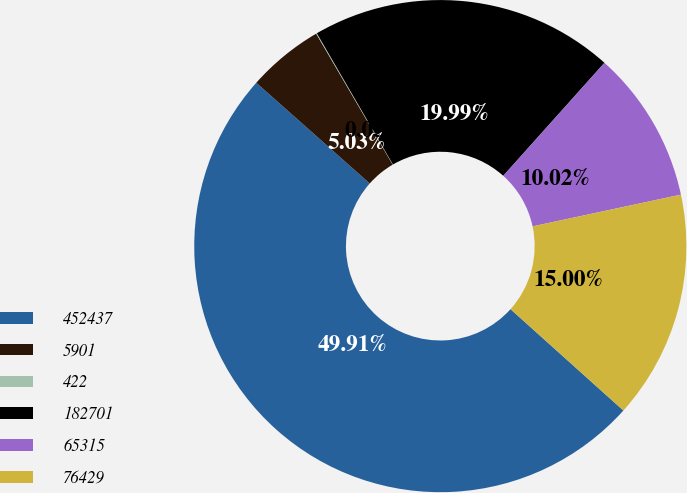Convert chart. <chart><loc_0><loc_0><loc_500><loc_500><pie_chart><fcel>452437<fcel>5901<fcel>422<fcel>182701<fcel>65315<fcel>76429<nl><fcel>49.91%<fcel>5.03%<fcel>0.05%<fcel>19.99%<fcel>10.02%<fcel>15.0%<nl></chart> 